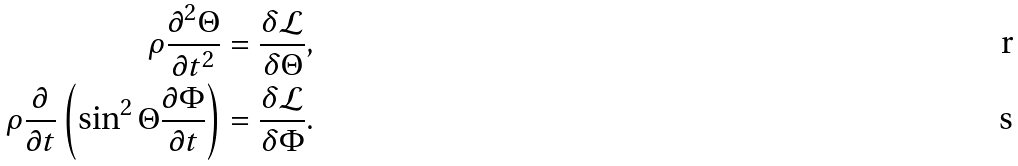<formula> <loc_0><loc_0><loc_500><loc_500>\rho \frac { \partial ^ { 2 } \Theta } { \partial t ^ { 2 } } = \frac { \delta \mathcal { L } } { \delta { \Theta } } , \\ \rho \frac { \partial } { \partial t } \left ( \sin ^ { 2 } \Theta \frac { \partial \Phi } { \partial t } \right ) = \frac { \delta \mathcal { L } } { \delta { \Phi } } .</formula> 